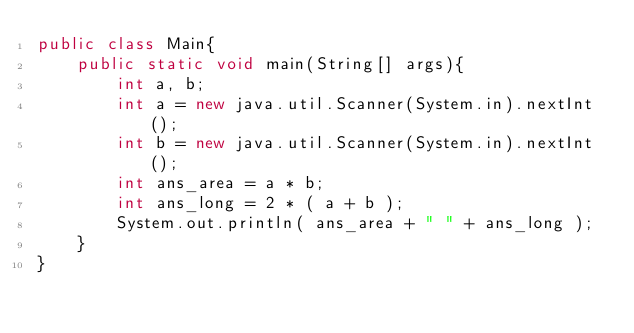Convert code to text. <code><loc_0><loc_0><loc_500><loc_500><_Java_>public class Main{
	public static void main(String[] args){
		int a, b;
		int a = new java.util.Scanner(System.in).nextInt();
		int b = new java.util.Scanner(System.in).nextInt();
		int ans_area = a * b;
		int ans_long = 2 * ( a + b );
		System.out.println( ans_area + " " + ans_long );
	}
}</code> 